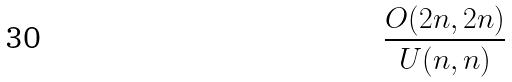Convert formula to latex. <formula><loc_0><loc_0><loc_500><loc_500>\frac { O ( 2 n , 2 n ) } { U ( n , n ) }</formula> 